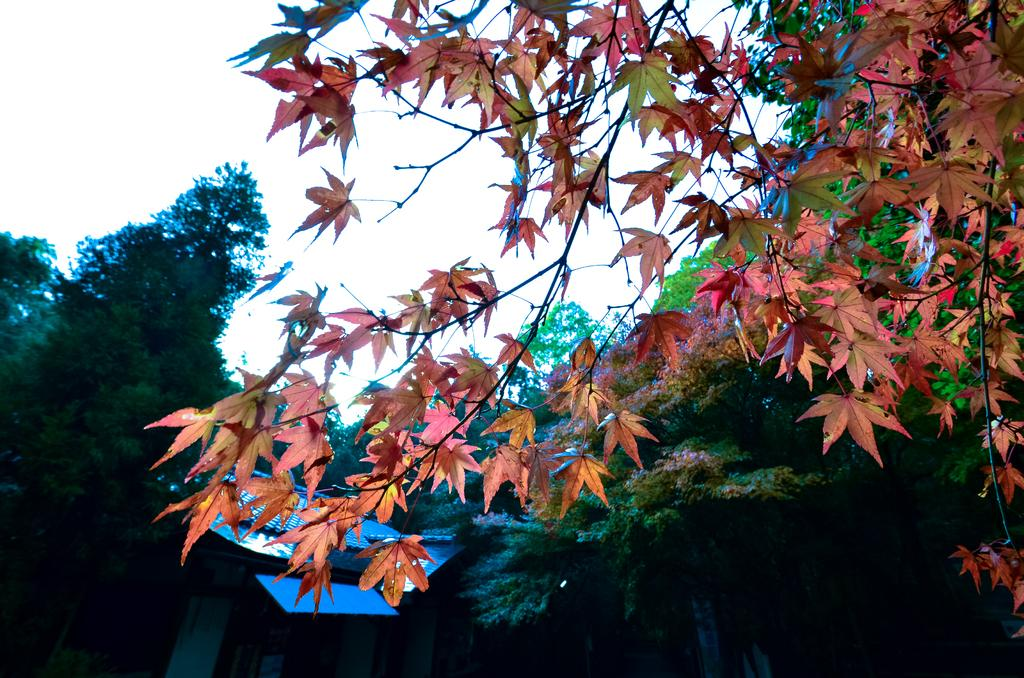What type of vegetation can be seen in the image? There are trees in the image. What type of structure is present in the image? There is a shed in the image. What is visible in the background of the image? The sky is visible in the image. What type of lamp can be seen hanging from the tree in the image? There is no lamp present in the image; it only features trees and a shed. What is the weight of the feather that is resting on the shed's roof in the image? There is no feather present in the image, so its weight cannot be determined. 